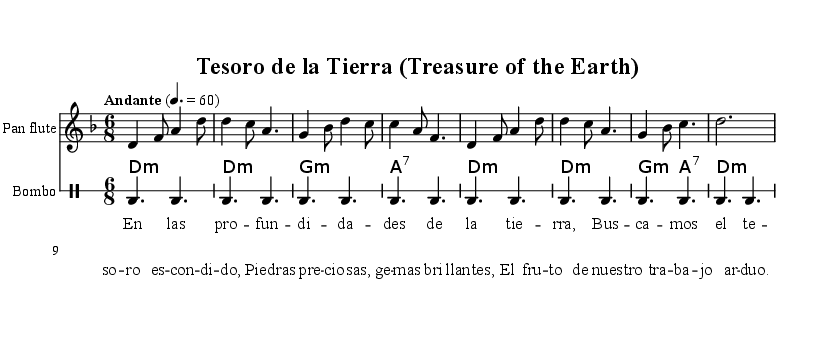What is the key signature of this music? The key signature is D minor, which is indicated by one flat in the music sheet.
Answer: D minor What is the time signature of this piece? The time signature is 6/8, which shows there are six eighth notes in each measure, as noted at the beginning of the sheet music.
Answer: 6/8 What is the tempo marking for this composition? The tempo marking is "Andante," which suggests a moderately slow pace for the piece, indicated at the start of the music.
Answer: Andante How many measures are in the first section played by the pan flute? The pan flute part contains a total of eight measures, which can be counted visually from the music notation.
Answer: Eight measures What instrument accompanies the pan flute in this score? The charango provides harmonic support to the pan flute through chord progressions, as shown in the sheet music.
Answer: Charango What is the main theme expressed in the lyrics? The lyrics refer to the quest for precious stones and the treasures of the earth, highlighting the theme of mining and labor.
Answer: Treasure of the Earth Which type of drumming pattern is used for the bombo? The drumming pattern for the bombo consists of consistent bass drum hits, providing a steady rhythm throughout the piece.
Answer: Bass drum 